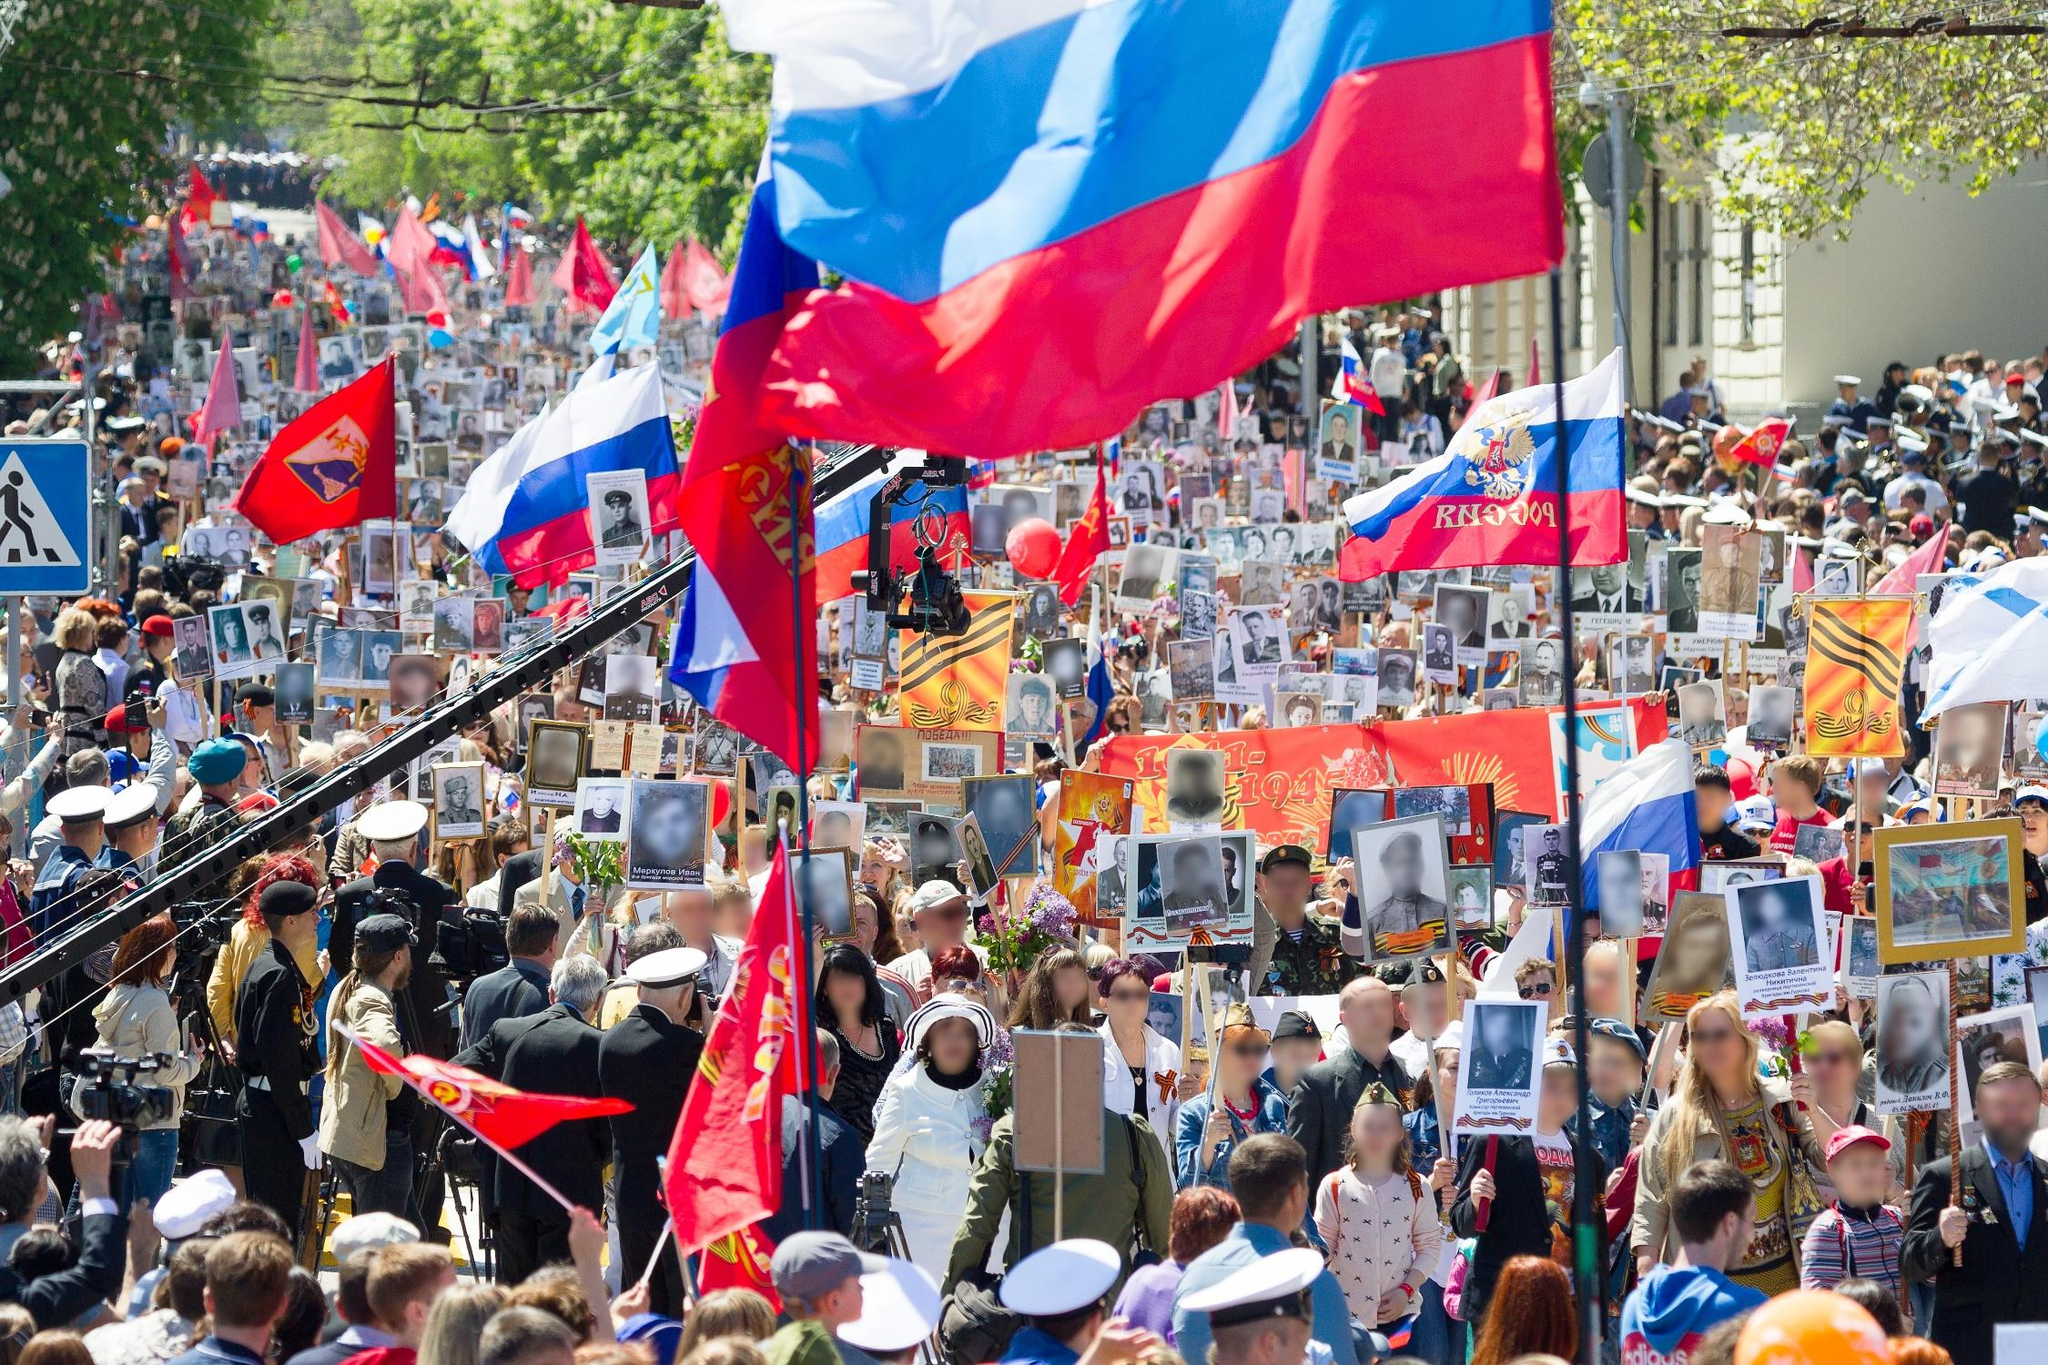Describe the types of flags being flown in the parade. In the parade, several flags are prominently displayed. Among them, the Russian national flag stands out with its white, blue, and red stripes. Intermixed are flags bearing Soviet-era symbols, such as the hammer and sickle, and red banners reminiscent of the Soviet Union. These flags contribute to the historical and commemorative atmosphere of the event. What might be the significance of holding photographs in this parade? The participants holding photographs during the parade likely do so to honor and remember soldiers, veterans, or important historical figures. This act of carrying images of loved ones and historical icons is a heartfelt gesture of remembrance, signifying respect and appreciation for their contributions and sacrifices. It transforms the parade into a living memorial, creating a powerful visual tribute to history and legacy. Imagine if one of the participants in the parade stepped into the past. What might they experience during the era shown in the photographs they are holding? Stepping into the era depicted in the photographs, a participant might find themselves amidst significant historical events, perhaps during the mid-20th century. They might witness the stark realities of life during wartime, the camaraderie and courage of soldiers, and the profound challenges faced by civilians. The streets would be markedly different—filled with vintage vehicles and people dressed in styles of that era. They'd experience the raw emotions of a time marred by conflict, yet also period marked by resilience and unity among the people. It would be a poignant journey, offering deeper understanding and connection to the history being commemorated in the parade. Considering the setting, what role do the surrounding buildings and trees play in the overall atmosphere of the parade? The surrounding buildings and trees serve as a contrasting backdrop to the vibrant and bustling scene of the parade. The urban setting, with its structured buildings, underscores the significance of the event taking place in a public and central area, suggesting its importance to the community. The trees, on the other hand, add a touch of natural beauty, offering a serene contrast to the dynamic and colorful assembly. Together, they frame the parade, highlighting its scale and significance while also situating it within the rhythm of everyday urban life. 